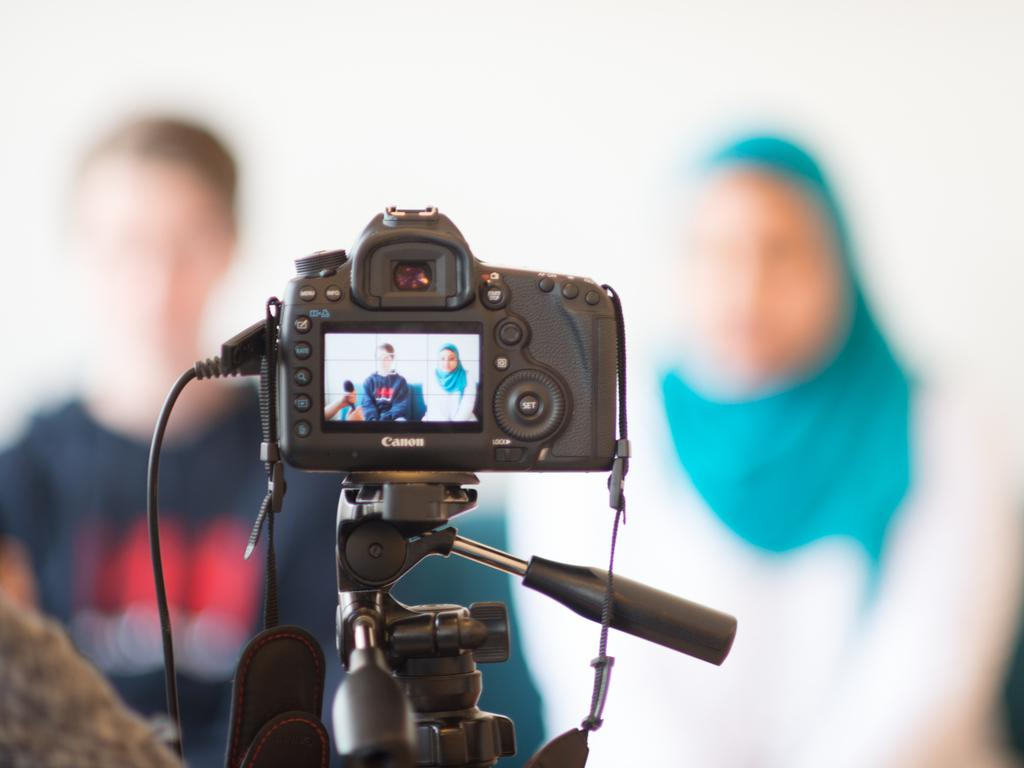What object is the main focus of the image? There is a camera in the image. How is the camera positioned in the image? The camera is on a stand. What feature is present on the camera? There is a screen on the camera. What can be seen on the screen? A woman and a man are sitting on a sofa on the screen. Can you describe the background of the image? The background of the image is slightly blurry. What type of harmony is being played by the leather writer in the image? There is no leather writer or harmony present in the image. 